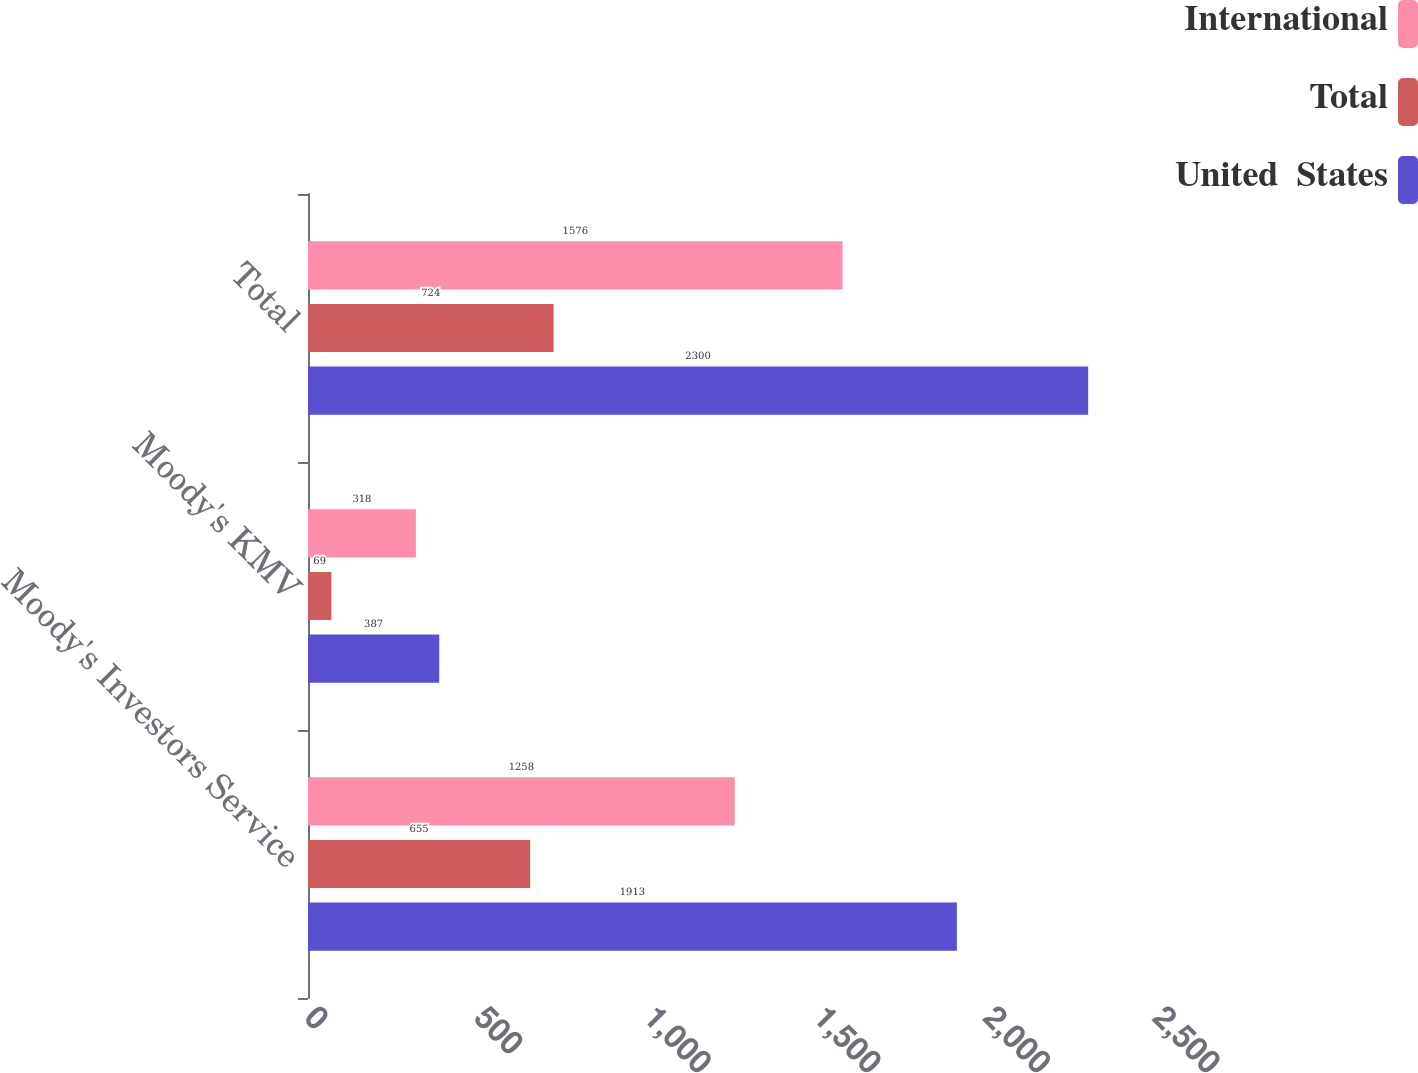Convert chart to OTSL. <chart><loc_0><loc_0><loc_500><loc_500><stacked_bar_chart><ecel><fcel>Moody's Investors Service<fcel>Moody's KMV<fcel>Total<nl><fcel>International<fcel>1258<fcel>318<fcel>1576<nl><fcel>Total<fcel>655<fcel>69<fcel>724<nl><fcel>United  States<fcel>1913<fcel>387<fcel>2300<nl></chart> 